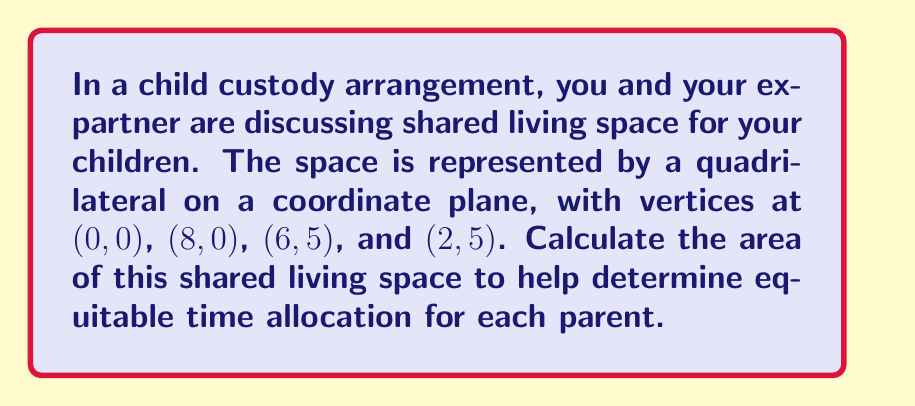What is the answer to this math problem? To find the area of the quadrilateral, we can split it into two triangles and sum their areas. Let's follow these steps:

1. Divide the quadrilateral into two triangles:
   Triangle 1: (0, 0), (8, 0), (6, 5)
   Triangle 2: (0, 0), (6, 5), (2, 5)

2. Use the formula for the area of a triangle given three points:
   $$A = \frac{1}{2}|x_1(y_2 - y_3) + x_2(y_3 - y_1) + x_3(y_1 - y_2)|$$

3. Calculate the area of Triangle 1:
   $$A_1 = \frac{1}{2}|0(0 - 5) + 8(5 - 0) + 6(0 - 0)| = \frac{1}{2}|0 + 40 + 0| = 20$$

4. Calculate the area of Triangle 2:
   $$A_2 = \frac{1}{2}|0(5 - 5) + 6(5 - 0) + 2(0 - 5)| = \frac{1}{2}|0 + 30 - 10| = 10$$

5. Sum the areas of both triangles:
   $$A_{total} = A_1 + A_2 = 20 + 10 = 30$$

Therefore, the total area of the shared living space is 30 square units.
Answer: 30 square units 